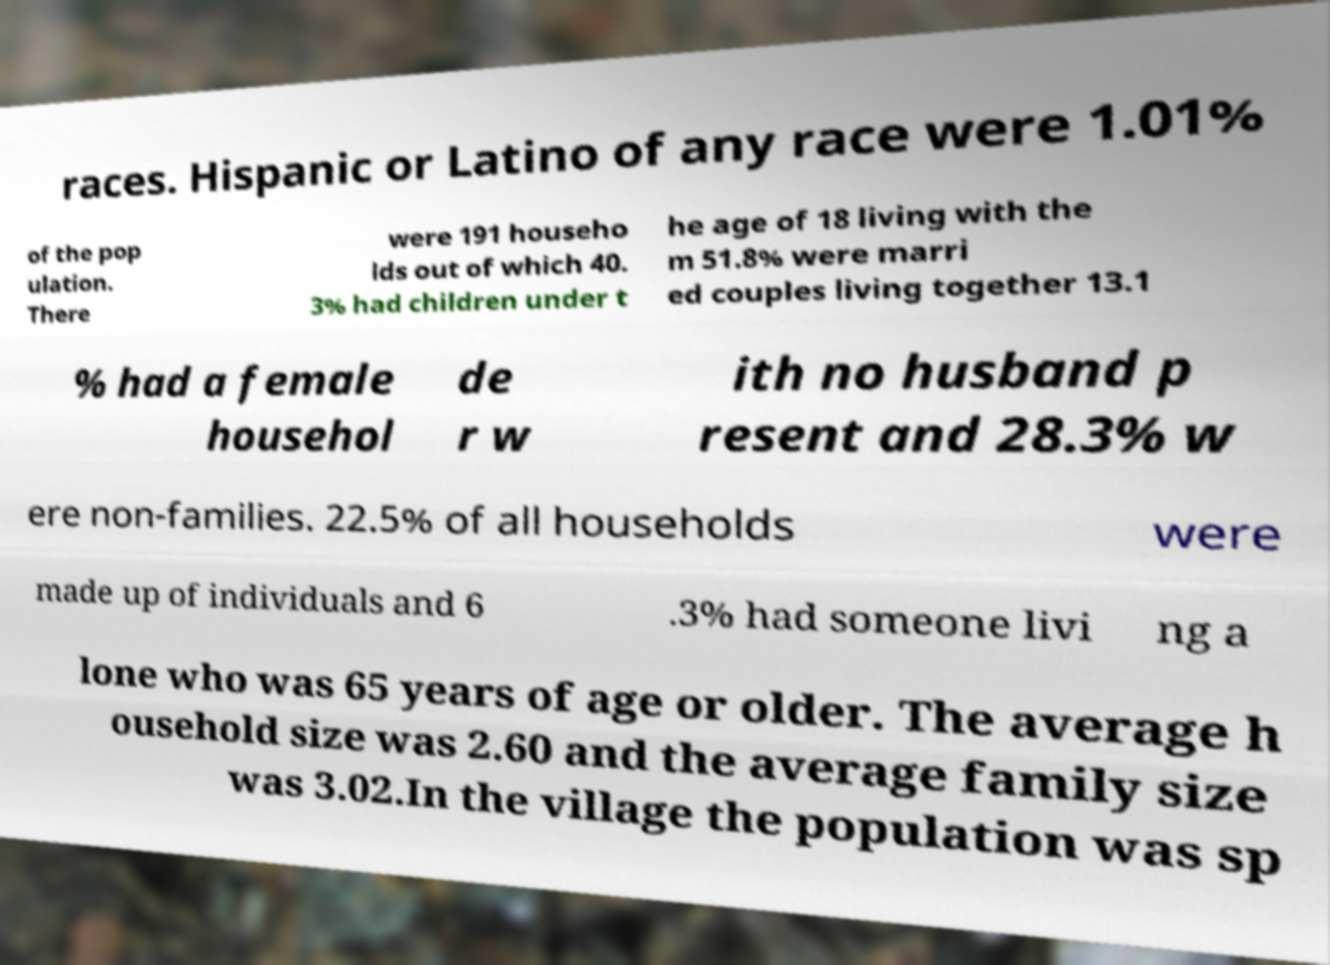Can you accurately transcribe the text from the provided image for me? races. Hispanic or Latino of any race were 1.01% of the pop ulation. There were 191 househo lds out of which 40. 3% had children under t he age of 18 living with the m 51.8% were marri ed couples living together 13.1 % had a female househol de r w ith no husband p resent and 28.3% w ere non-families. 22.5% of all households were made up of individuals and 6 .3% had someone livi ng a lone who was 65 years of age or older. The average h ousehold size was 2.60 and the average family size was 3.02.In the village the population was sp 